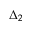Convert formula to latex. <formula><loc_0><loc_0><loc_500><loc_500>\Delta _ { 2 }</formula> 